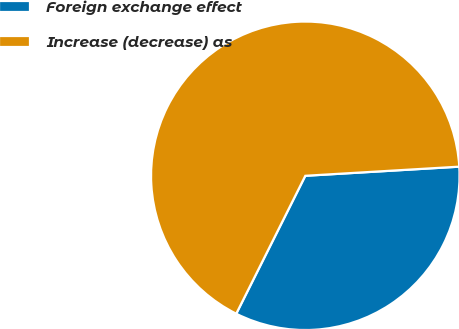Convert chart to OTSL. <chart><loc_0><loc_0><loc_500><loc_500><pie_chart><fcel>Foreign exchange effect<fcel>Increase (decrease) as<nl><fcel>33.33%<fcel>66.67%<nl></chart> 